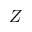<formula> <loc_0><loc_0><loc_500><loc_500>Z</formula> 